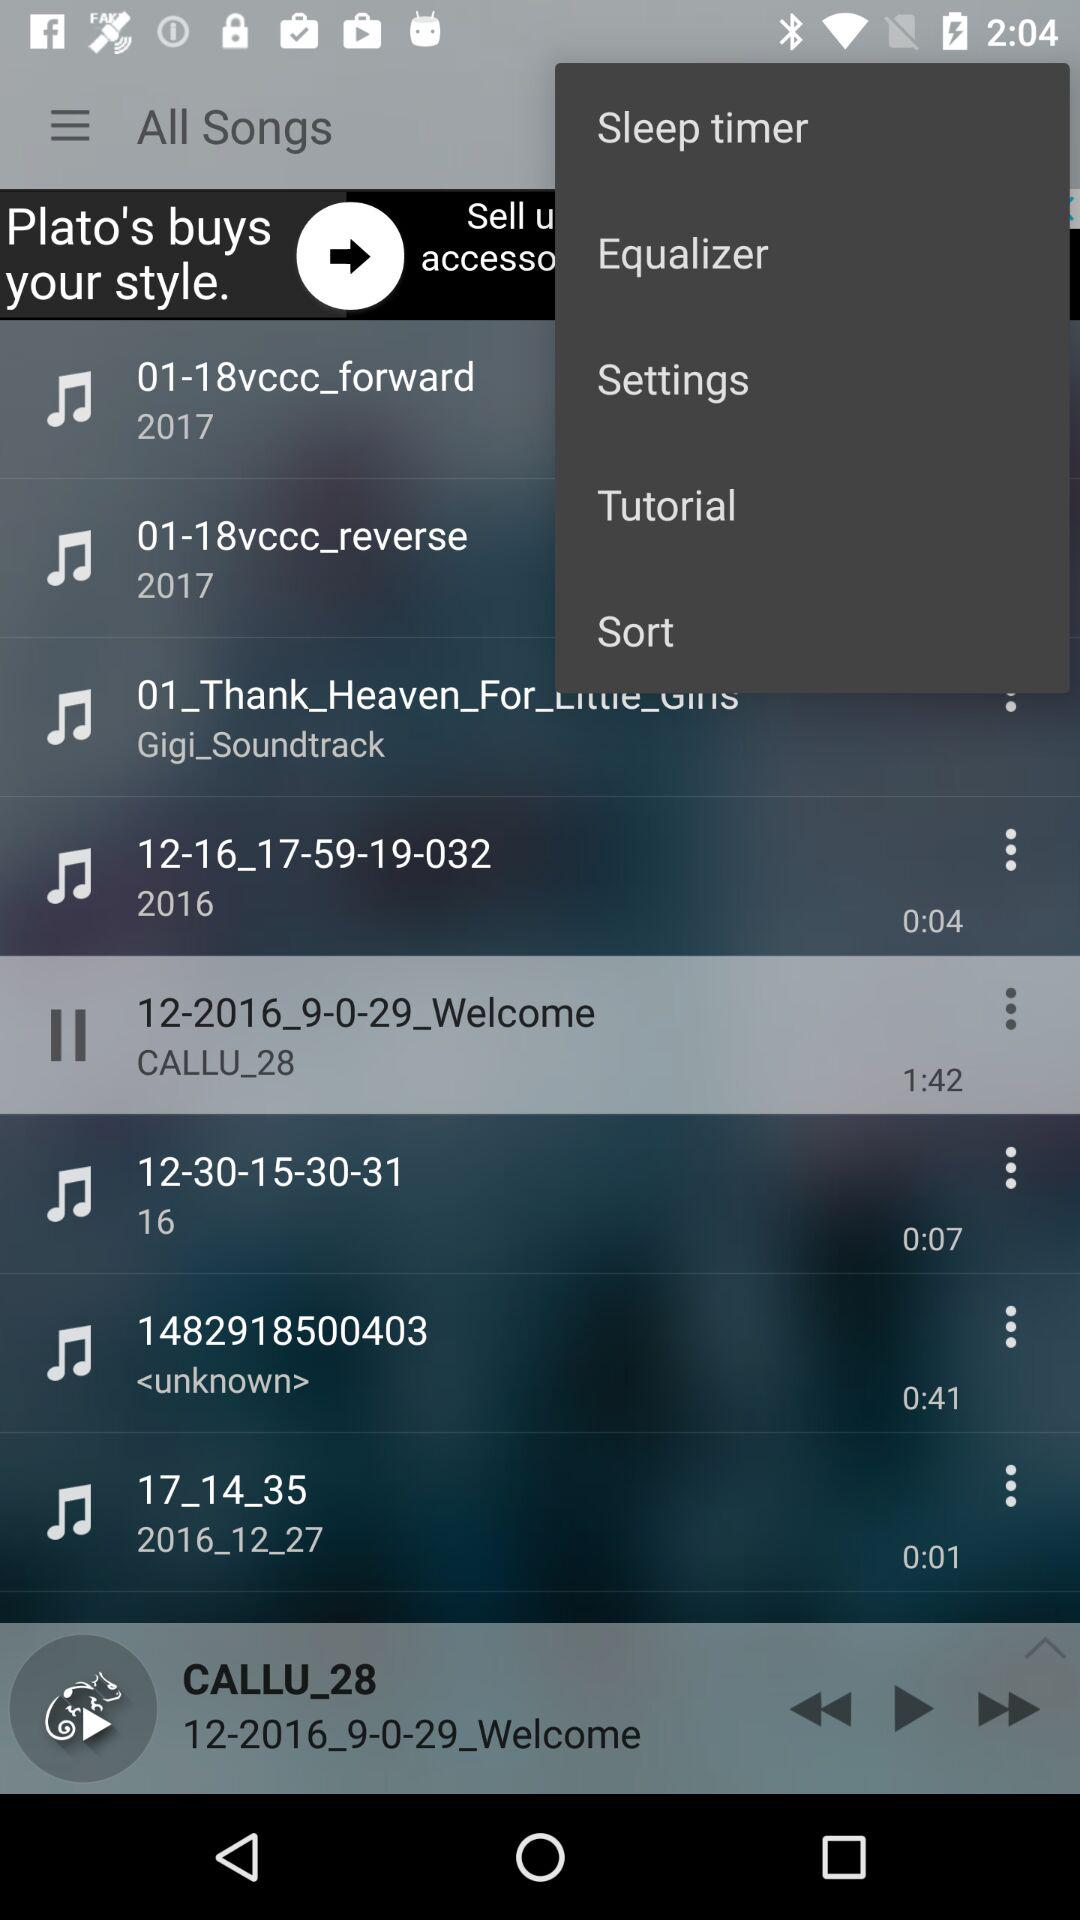Which song is playing currently? The song currently playing is "12-2016_9-0-29_Welcome". 